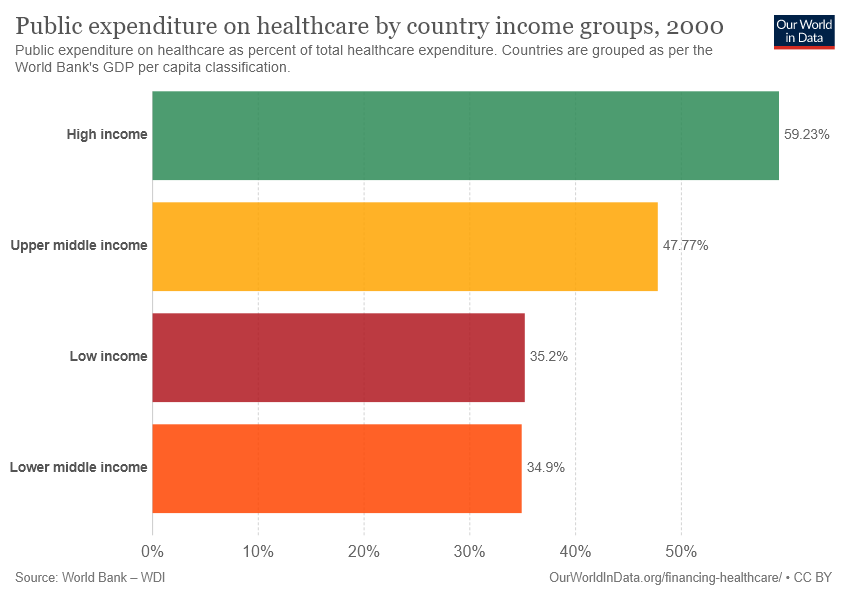Identify some key points in this picture. The difference between the smallest two bars is 0.3 The value of the yellow bar is 47.77, as indicated by the decimal point following the first numeral. 